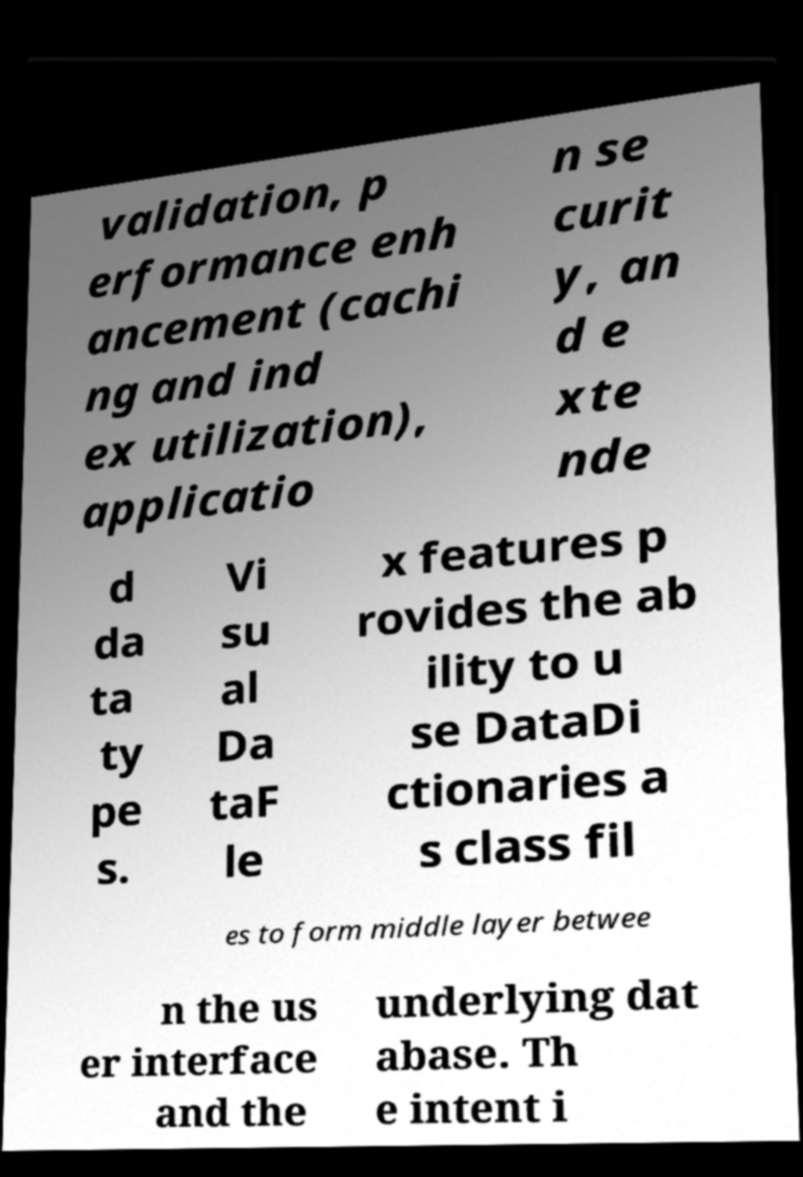Could you extract and type out the text from this image? validation, p erformance enh ancement (cachi ng and ind ex utilization), applicatio n se curit y, an d e xte nde d da ta ty pe s. Vi su al Da taF le x features p rovides the ab ility to u se DataDi ctionaries a s class fil es to form middle layer betwee n the us er interface and the underlying dat abase. Th e intent i 